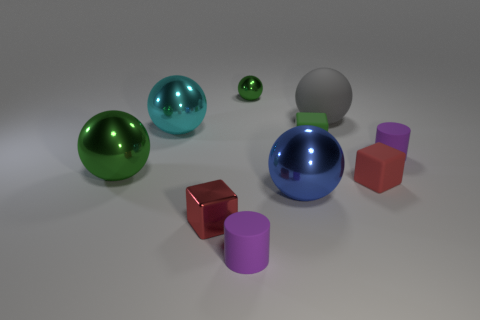Subtract all blue spheres. How many spheres are left? 4 Subtract all gray spheres. How many spheres are left? 4 Subtract all brown balls. Subtract all green blocks. How many balls are left? 5 Subtract all cylinders. How many objects are left? 8 Add 8 small purple rubber things. How many small purple rubber things are left? 10 Add 3 big shiny objects. How many big shiny objects exist? 6 Subtract 0 yellow blocks. How many objects are left? 10 Subtract all tiny green cubes. Subtract all big objects. How many objects are left? 5 